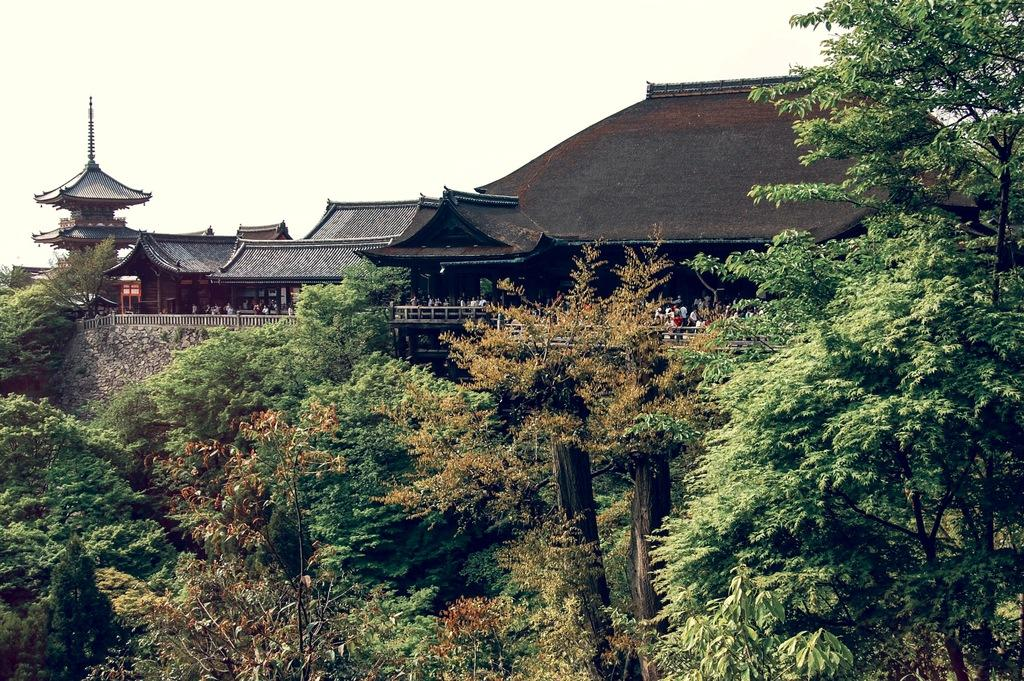What type of natural elements can be seen in the image? There are trees in the image. What type of man-made structures are present in the image? There are ancient architectural buildings in the image. What might be used for safety or support in the image? There is a railing in the image. Who or what is present in the image? There are people in the image. What is visible in the background of the image? The sky is visible in the image. Can you tell me how many fish are swimming in the river in the image? There is no river or fish present in the image; it features trees, ancient architectural buildings, a railing, people, and the sky. What type of bird is perched on the wren in the image? There is no wren present in the image. 